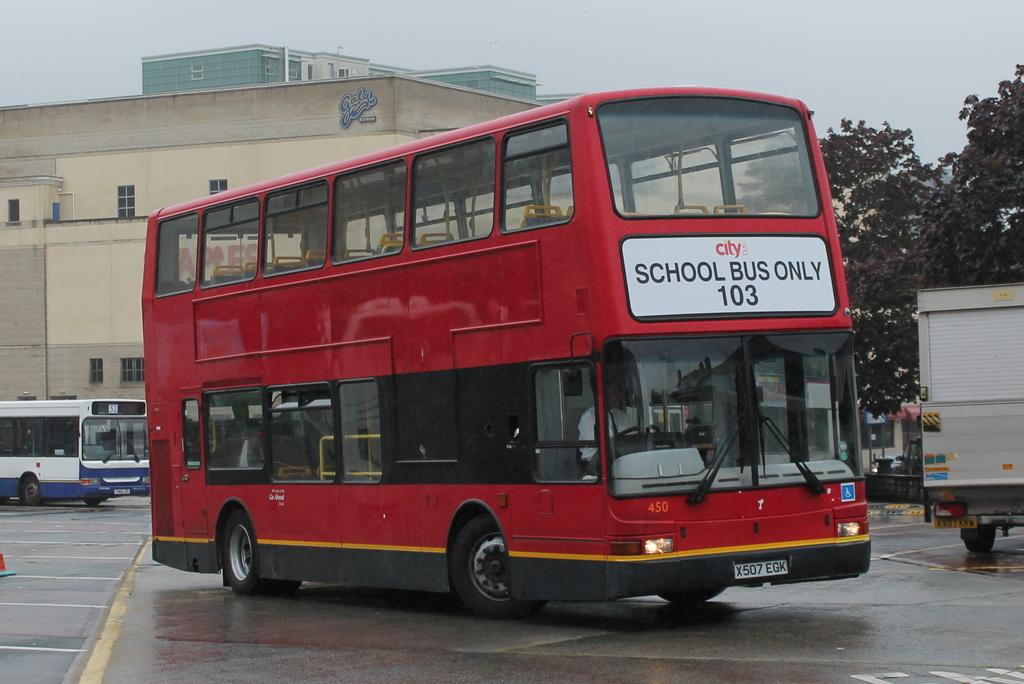<image>
Relay a brief, clear account of the picture shown. a double stacked red bus number 103 written on the front 